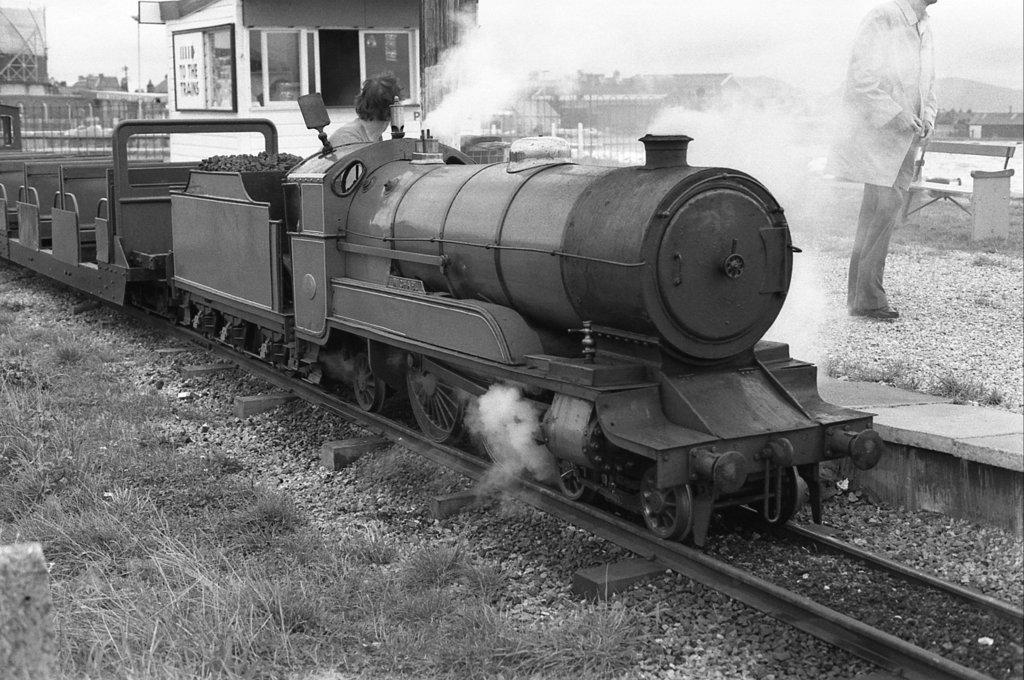<image>
Create a compact narrative representing the image presented. A small shack next to a train track has a sign that includes a word starting with the letter T on it. 